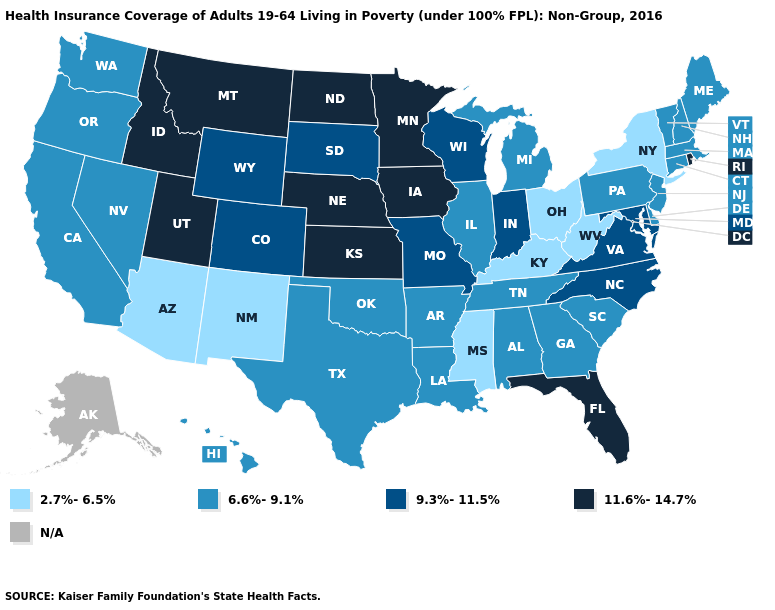Among the states that border Nebraska , does Kansas have the lowest value?
Write a very short answer. No. Which states hav the highest value in the South?
Concise answer only. Florida. Does the map have missing data?
Keep it brief. Yes. What is the value of North Carolina?
Short answer required. 9.3%-11.5%. What is the value of Missouri?
Keep it brief. 9.3%-11.5%. Name the states that have a value in the range 6.6%-9.1%?
Keep it brief. Alabama, Arkansas, California, Connecticut, Delaware, Georgia, Hawaii, Illinois, Louisiana, Maine, Massachusetts, Michigan, Nevada, New Hampshire, New Jersey, Oklahoma, Oregon, Pennsylvania, South Carolina, Tennessee, Texas, Vermont, Washington. What is the value of Idaho?
Be succinct. 11.6%-14.7%. Does the map have missing data?
Quick response, please. Yes. Among the states that border Massachusetts , does Vermont have the highest value?
Write a very short answer. No. Which states have the lowest value in the Northeast?
Short answer required. New York. What is the lowest value in states that border Pennsylvania?
Concise answer only. 2.7%-6.5%. What is the highest value in states that border New Hampshire?
Concise answer only. 6.6%-9.1%. What is the highest value in the USA?
Be succinct. 11.6%-14.7%. Name the states that have a value in the range 11.6%-14.7%?
Answer briefly. Florida, Idaho, Iowa, Kansas, Minnesota, Montana, Nebraska, North Dakota, Rhode Island, Utah. 